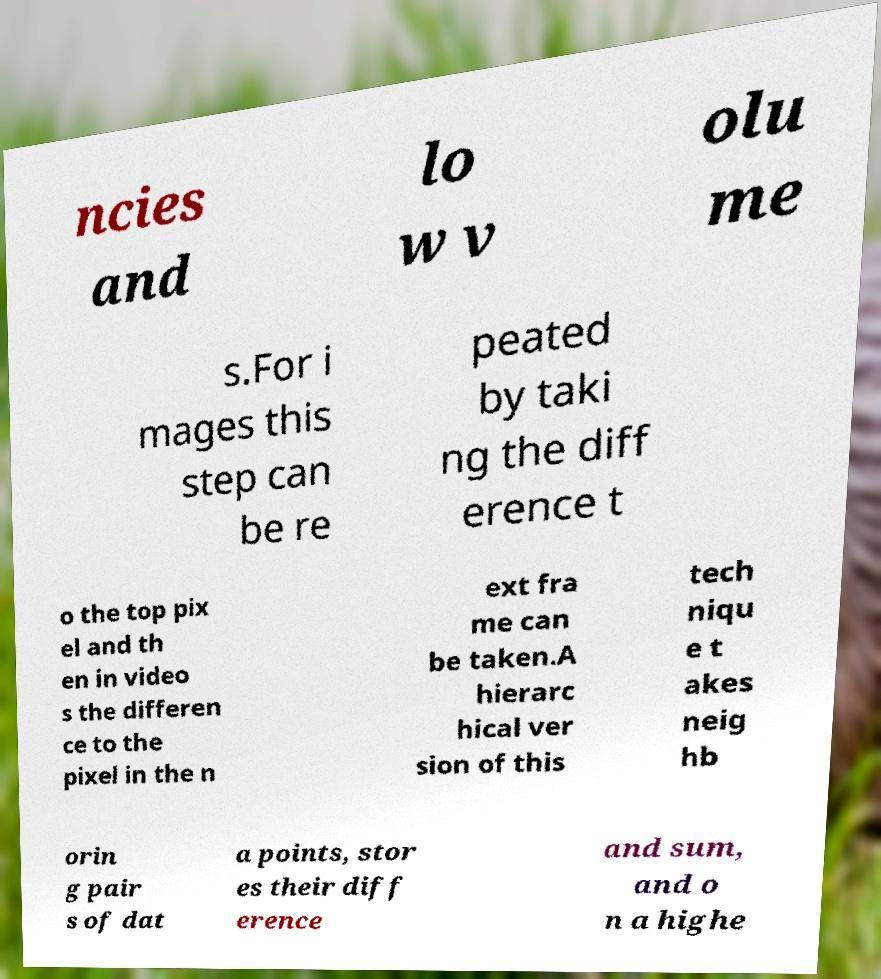Can you read and provide the text displayed in the image?This photo seems to have some interesting text. Can you extract and type it out for me? ncies and lo w v olu me s.For i mages this step can be re peated by taki ng the diff erence t o the top pix el and th en in video s the differen ce to the pixel in the n ext fra me can be taken.A hierarc hical ver sion of this tech niqu e t akes neig hb orin g pair s of dat a points, stor es their diff erence and sum, and o n a highe 